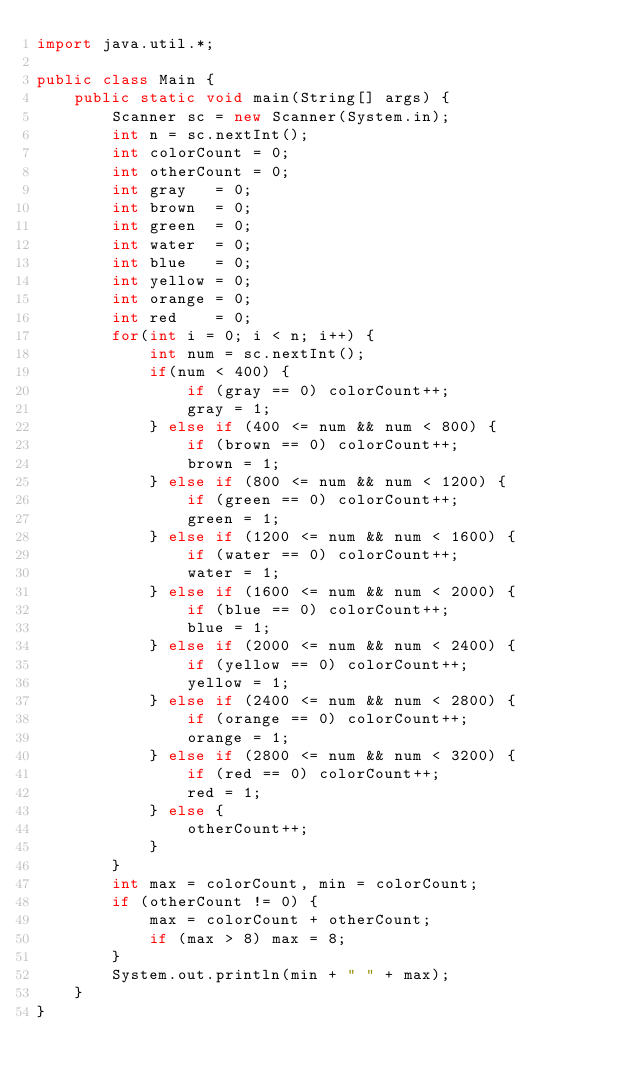<code> <loc_0><loc_0><loc_500><loc_500><_Java_>import java.util.*;

public class Main {
    public static void main(String[] args) {
        Scanner sc = new Scanner(System.in);
        int n = sc.nextInt();
        int colorCount = 0;
        int otherCount = 0;
        int gray   = 0;
        int brown  = 0;
        int green  = 0;
        int water  = 0;
        int blue   = 0;
        int yellow = 0;
        int orange = 0;
        int red    = 0;
        for(int i = 0; i < n; i++) {
            int num = sc.nextInt();
            if(num < 400) {
                if (gray == 0) colorCount++;
                gray = 1;
            } else if (400 <= num && num < 800) {
                if (brown == 0) colorCount++;
                brown = 1;
            } else if (800 <= num && num < 1200) {
                if (green == 0) colorCount++;
                green = 1;
            } else if (1200 <= num && num < 1600) {
                if (water == 0) colorCount++;
                water = 1;
            } else if (1600 <= num && num < 2000) {
                if (blue == 0) colorCount++;
                blue = 1;
            } else if (2000 <= num && num < 2400) {
                if (yellow == 0) colorCount++;
                yellow = 1;
            } else if (2400 <= num && num < 2800) {
                if (orange == 0) colorCount++;
                orange = 1;
            } else if (2800 <= num && num < 3200) {
                if (red == 0) colorCount++;
                red = 1;
            } else {
                otherCount++;
            }
        }
        int max = colorCount, min = colorCount;
        if (otherCount != 0) {
            max = colorCount + otherCount;
            if (max > 8) max = 8;
        }
        System.out.println(min + " " + max);
    }
}</code> 